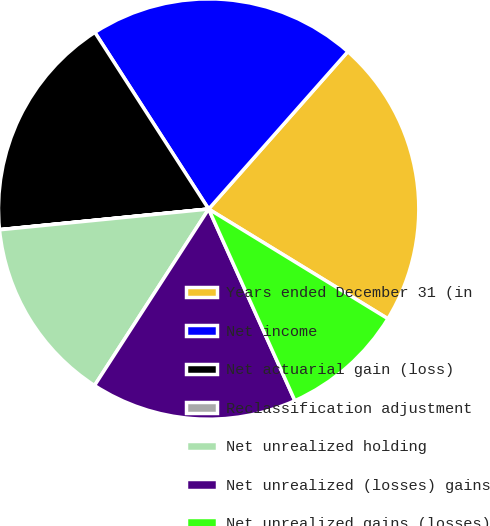Convert chart to OTSL. <chart><loc_0><loc_0><loc_500><loc_500><pie_chart><fcel>Years ended December 31 (in<fcel>Net income<fcel>Net actuarial gain (loss)<fcel>Reclassification adjustment<fcel>Net unrealized holding<fcel>Net unrealized (losses) gains<fcel>Net unrealized gains (losses)<nl><fcel>22.22%<fcel>20.63%<fcel>17.46%<fcel>0.01%<fcel>14.29%<fcel>15.87%<fcel>9.53%<nl></chart> 